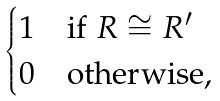<formula> <loc_0><loc_0><loc_500><loc_500>\begin{cases} 1 & \text {if } R \cong R ^ { \prime } \\ 0 & \text {otherwise,} \end{cases}</formula> 